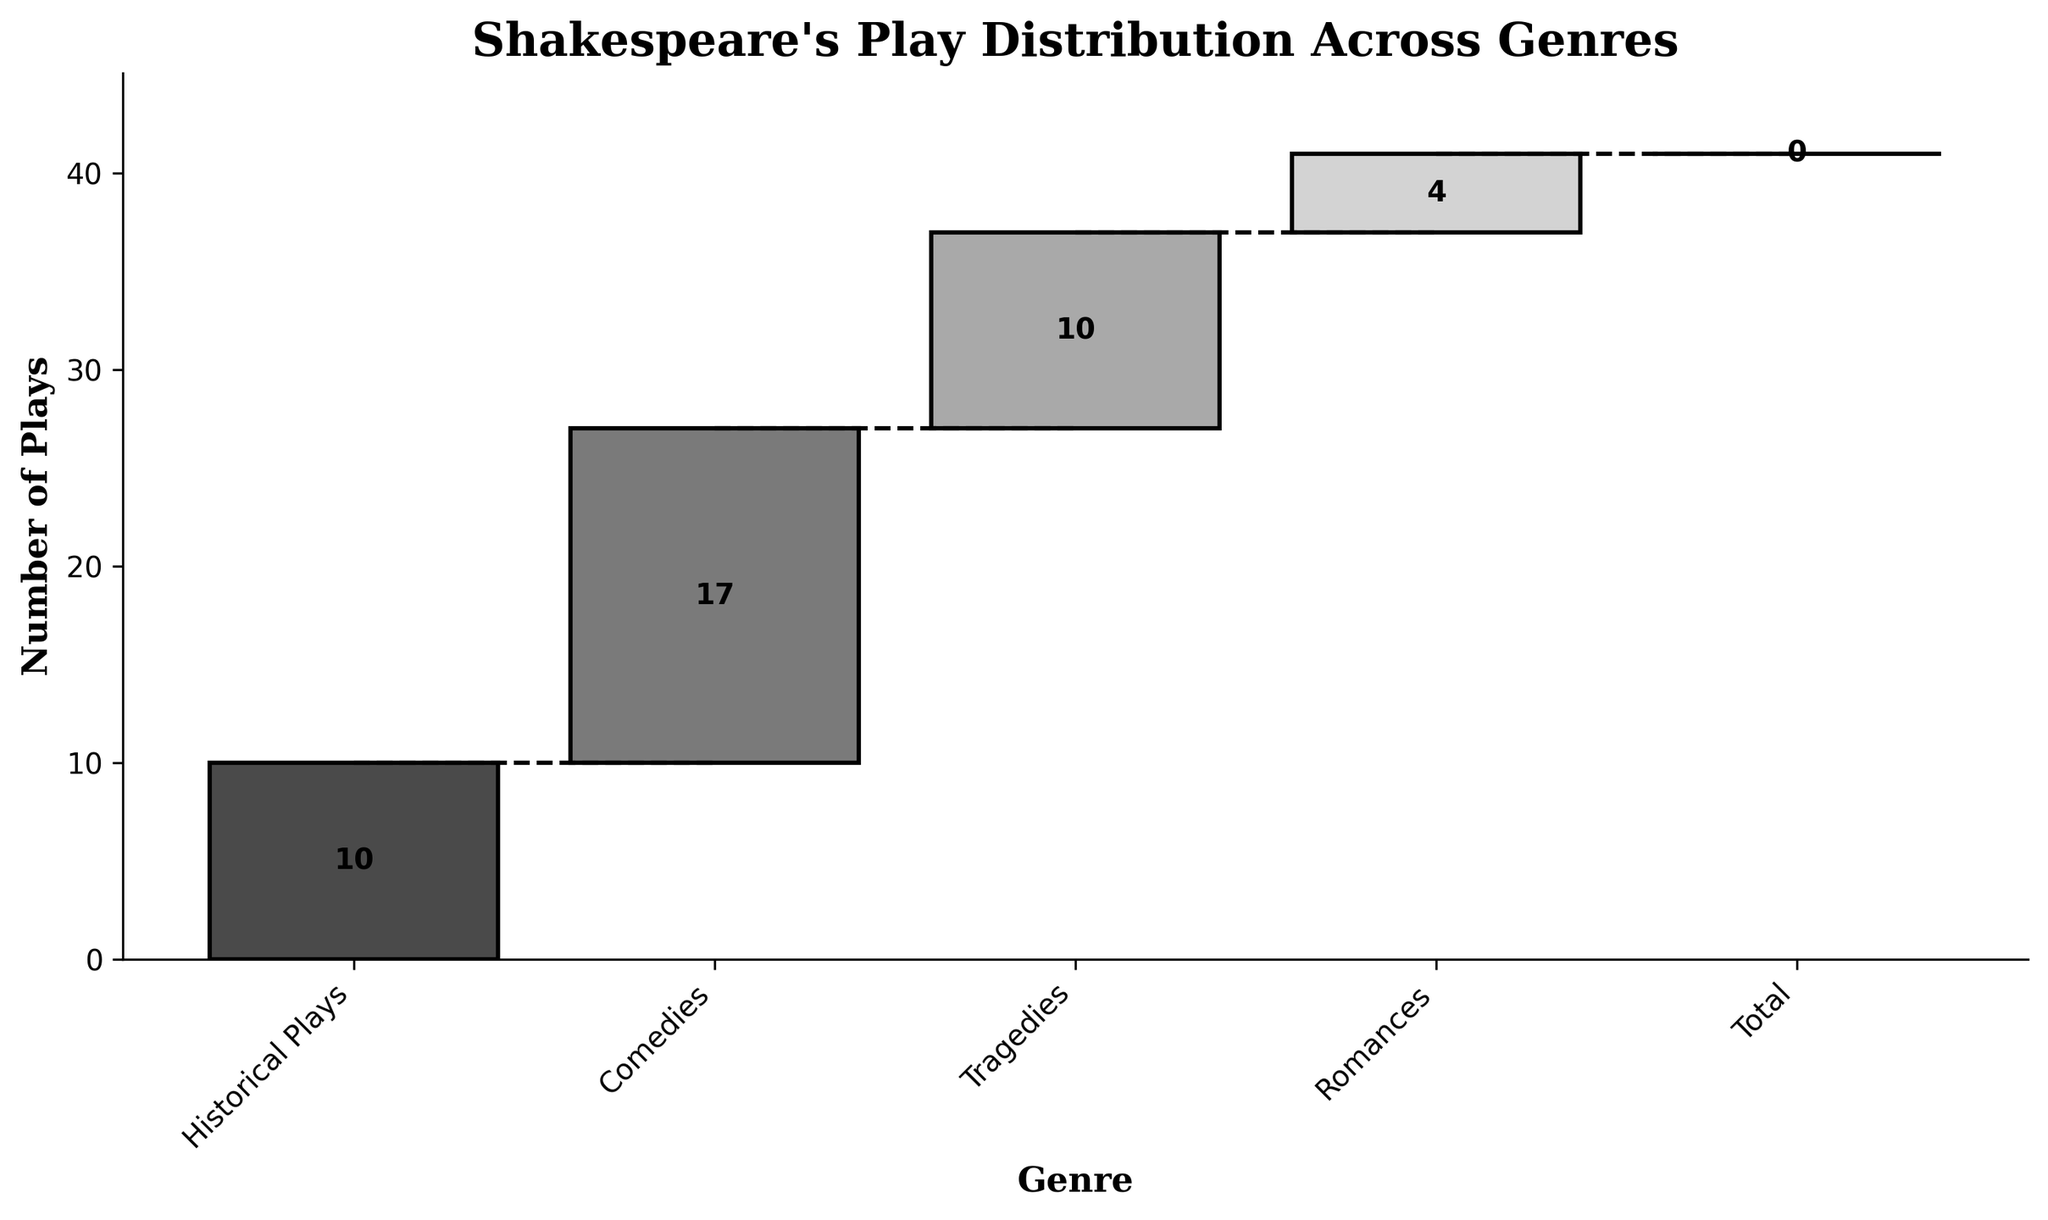What is the cumulative number of plays in Comedies? The cumulative number of plays for Comedies can be observed from the Chart, starting from 10 Historical Plays and adding 17 Comedies, so the cumulative number of plays is 27
Answer: 27 Which genre contributes the most plays? By looking at the heights of the bars, the Comedies genre has the highest number of plays with 17 contributions
Answer: Comedies How many genres are plotted in the figure? By counting the distinct genres from the figure, 4 genres (Historical Plays, Comedies, Tragedies, Romances) are plotted, excluding the Total
Answer: 4 What is the total number of plays in Shakespeare's works according to the chart? The total number is indicated at the end of the waterfall chart, which sums up to 41
Answer: 41 What is the difference in the number of plays between Tragedies and Romances? Tragedies have 10 plays, Romances have 4 plays. The difference is 10 - 4
Answer: 6 Does any genre have a decline in the cumulative number of plays? Observing the bars in the waterfall chart, no genre shows a decline; all values are positive
Answer: No How do the plays in Historical Plays compare to those in Romances? Historical Plays have 10 plays whereas Romances have 4 plays. Historical Plays have 6 more plays than Romances
Answer: Historical Plays have 6 more plays What is the trend from Historical Plays to Tragedies in terms of cumulative values? Starting from 10 Historical Plays, adding 17 Comedies results in 27, which then adds 10 Tragedies resulting in 37. The cumulative trend is increasing
Answer: Increasing trend How many more Tragedies are there compared to Romances? Tragedies have 10 plays, while Romances have 4. The difference is 10 - 4
Answer: 6 